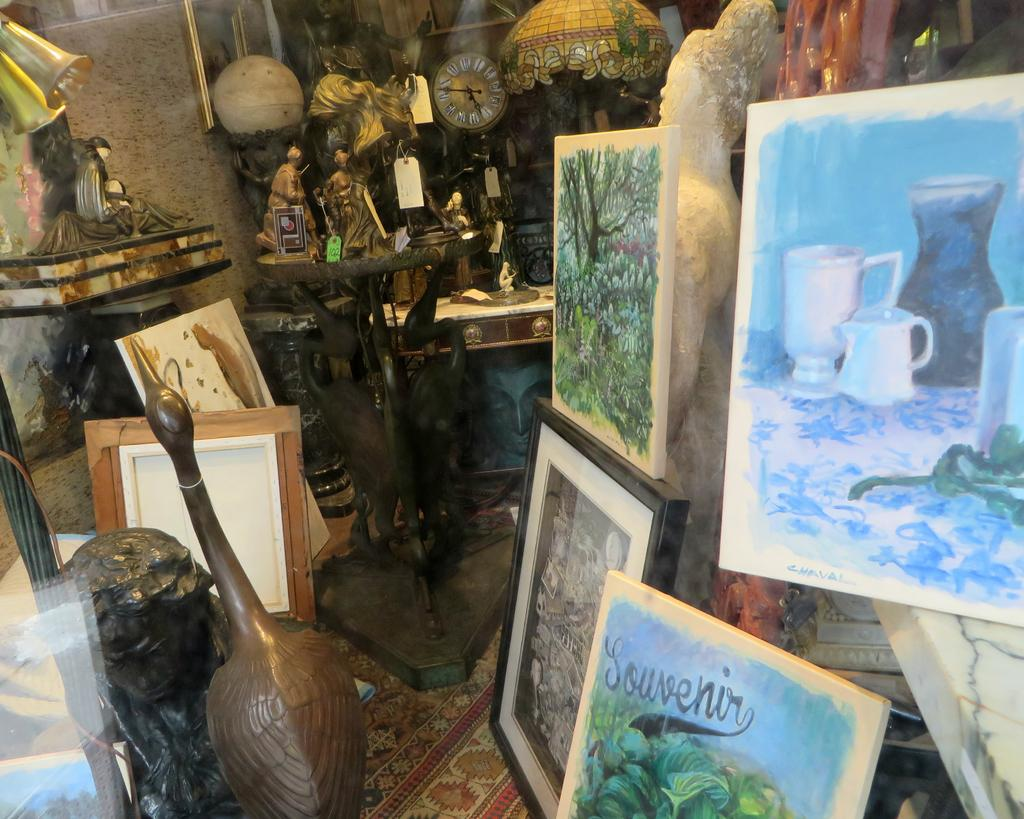What type of decorative items can be seen on the right side of the image? There are painted photo frames on the right side of the image. What artistic piece is located on the left side of the image? There is a sculpture on the left side of the image. What objects are in the middle of the image? There are balls in the middle of the image. What type of root can be seen growing in the image? There is no root present in the image. What advice might the mom give in the image? There is no mom present in the image, so it is not possible to determine what advice she might give. 